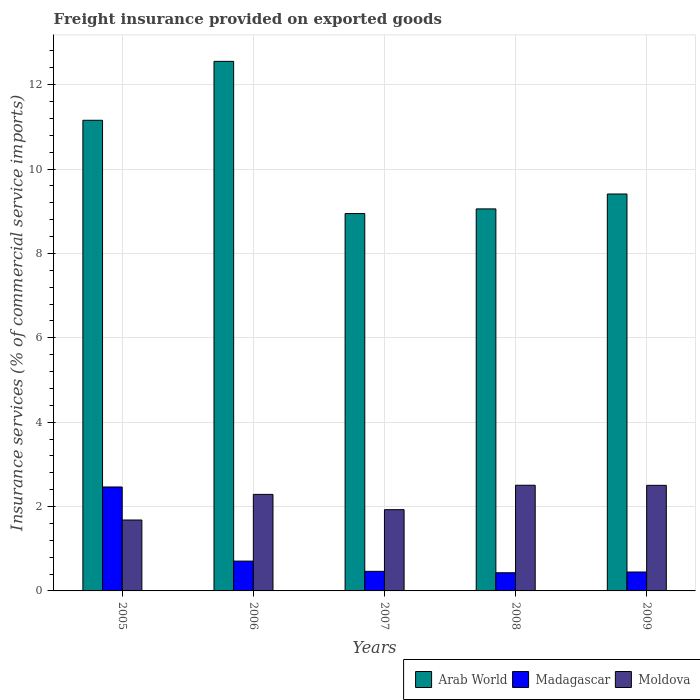How many different coloured bars are there?
Give a very brief answer. 3. How many groups of bars are there?
Ensure brevity in your answer.  5. How many bars are there on the 4th tick from the left?
Offer a very short reply. 3. What is the freight insurance provided on exported goods in Madagascar in 2007?
Your answer should be very brief. 0.46. Across all years, what is the maximum freight insurance provided on exported goods in Moldova?
Make the answer very short. 2.51. Across all years, what is the minimum freight insurance provided on exported goods in Moldova?
Offer a terse response. 1.68. In which year was the freight insurance provided on exported goods in Madagascar maximum?
Your answer should be compact. 2005. In which year was the freight insurance provided on exported goods in Moldova minimum?
Your answer should be compact. 2005. What is the total freight insurance provided on exported goods in Arab World in the graph?
Your answer should be compact. 51.12. What is the difference between the freight insurance provided on exported goods in Moldova in 2007 and that in 2008?
Offer a very short reply. -0.58. What is the difference between the freight insurance provided on exported goods in Moldova in 2008 and the freight insurance provided on exported goods in Madagascar in 2005?
Your response must be concise. 0.04. What is the average freight insurance provided on exported goods in Arab World per year?
Your answer should be compact. 10.22. In the year 2007, what is the difference between the freight insurance provided on exported goods in Arab World and freight insurance provided on exported goods in Moldova?
Provide a succinct answer. 7.02. In how many years, is the freight insurance provided on exported goods in Moldova greater than 3.6 %?
Give a very brief answer. 0. What is the ratio of the freight insurance provided on exported goods in Moldova in 2008 to that in 2009?
Ensure brevity in your answer.  1. Is the freight insurance provided on exported goods in Arab World in 2005 less than that in 2007?
Give a very brief answer. No. Is the difference between the freight insurance provided on exported goods in Arab World in 2007 and 2009 greater than the difference between the freight insurance provided on exported goods in Moldova in 2007 and 2009?
Your response must be concise. Yes. What is the difference between the highest and the second highest freight insurance provided on exported goods in Moldova?
Provide a succinct answer. 0. What is the difference between the highest and the lowest freight insurance provided on exported goods in Madagascar?
Make the answer very short. 2.03. In how many years, is the freight insurance provided on exported goods in Moldova greater than the average freight insurance provided on exported goods in Moldova taken over all years?
Your response must be concise. 3. Is the sum of the freight insurance provided on exported goods in Arab World in 2005 and 2009 greater than the maximum freight insurance provided on exported goods in Madagascar across all years?
Make the answer very short. Yes. What does the 2nd bar from the left in 2005 represents?
Your answer should be very brief. Madagascar. What does the 3rd bar from the right in 2008 represents?
Offer a very short reply. Arab World. Is it the case that in every year, the sum of the freight insurance provided on exported goods in Arab World and freight insurance provided on exported goods in Madagascar is greater than the freight insurance provided on exported goods in Moldova?
Keep it short and to the point. Yes. How many bars are there?
Keep it short and to the point. 15. Are all the bars in the graph horizontal?
Your answer should be very brief. No. How many years are there in the graph?
Provide a short and direct response. 5. What is the difference between two consecutive major ticks on the Y-axis?
Your answer should be compact. 2. Does the graph contain any zero values?
Your response must be concise. No. Does the graph contain grids?
Your answer should be compact. Yes. What is the title of the graph?
Make the answer very short. Freight insurance provided on exported goods. Does "Kuwait" appear as one of the legend labels in the graph?
Ensure brevity in your answer.  No. What is the label or title of the Y-axis?
Make the answer very short. Insurance services (% of commercial service imports). What is the Insurance services (% of commercial service imports) in Arab World in 2005?
Give a very brief answer. 11.16. What is the Insurance services (% of commercial service imports) in Madagascar in 2005?
Your response must be concise. 2.46. What is the Insurance services (% of commercial service imports) of Moldova in 2005?
Give a very brief answer. 1.68. What is the Insurance services (% of commercial service imports) of Arab World in 2006?
Your answer should be compact. 12.55. What is the Insurance services (% of commercial service imports) in Madagascar in 2006?
Provide a succinct answer. 0.71. What is the Insurance services (% of commercial service imports) of Moldova in 2006?
Provide a short and direct response. 2.29. What is the Insurance services (% of commercial service imports) in Arab World in 2007?
Your response must be concise. 8.95. What is the Insurance services (% of commercial service imports) of Madagascar in 2007?
Your answer should be compact. 0.46. What is the Insurance services (% of commercial service imports) of Moldova in 2007?
Ensure brevity in your answer.  1.93. What is the Insurance services (% of commercial service imports) in Arab World in 2008?
Offer a very short reply. 9.06. What is the Insurance services (% of commercial service imports) in Madagascar in 2008?
Give a very brief answer. 0.43. What is the Insurance services (% of commercial service imports) in Moldova in 2008?
Your response must be concise. 2.51. What is the Insurance services (% of commercial service imports) in Arab World in 2009?
Offer a terse response. 9.41. What is the Insurance services (% of commercial service imports) in Madagascar in 2009?
Make the answer very short. 0.45. What is the Insurance services (% of commercial service imports) of Moldova in 2009?
Give a very brief answer. 2.5. Across all years, what is the maximum Insurance services (% of commercial service imports) of Arab World?
Keep it short and to the point. 12.55. Across all years, what is the maximum Insurance services (% of commercial service imports) in Madagascar?
Ensure brevity in your answer.  2.46. Across all years, what is the maximum Insurance services (% of commercial service imports) in Moldova?
Keep it short and to the point. 2.51. Across all years, what is the minimum Insurance services (% of commercial service imports) in Arab World?
Make the answer very short. 8.95. Across all years, what is the minimum Insurance services (% of commercial service imports) of Madagascar?
Make the answer very short. 0.43. Across all years, what is the minimum Insurance services (% of commercial service imports) of Moldova?
Your answer should be compact. 1.68. What is the total Insurance services (% of commercial service imports) in Arab World in the graph?
Your answer should be compact. 51.12. What is the total Insurance services (% of commercial service imports) in Madagascar in the graph?
Keep it short and to the point. 4.51. What is the total Insurance services (% of commercial service imports) of Moldova in the graph?
Your answer should be very brief. 10.9. What is the difference between the Insurance services (% of commercial service imports) in Arab World in 2005 and that in 2006?
Provide a short and direct response. -1.4. What is the difference between the Insurance services (% of commercial service imports) in Madagascar in 2005 and that in 2006?
Offer a terse response. 1.76. What is the difference between the Insurance services (% of commercial service imports) of Moldova in 2005 and that in 2006?
Give a very brief answer. -0.61. What is the difference between the Insurance services (% of commercial service imports) in Arab World in 2005 and that in 2007?
Give a very brief answer. 2.21. What is the difference between the Insurance services (% of commercial service imports) of Madagascar in 2005 and that in 2007?
Your answer should be very brief. 2. What is the difference between the Insurance services (% of commercial service imports) in Moldova in 2005 and that in 2007?
Your answer should be very brief. -0.25. What is the difference between the Insurance services (% of commercial service imports) in Arab World in 2005 and that in 2008?
Your answer should be very brief. 2.1. What is the difference between the Insurance services (% of commercial service imports) in Madagascar in 2005 and that in 2008?
Your answer should be compact. 2.03. What is the difference between the Insurance services (% of commercial service imports) in Moldova in 2005 and that in 2008?
Provide a succinct answer. -0.82. What is the difference between the Insurance services (% of commercial service imports) in Arab World in 2005 and that in 2009?
Your response must be concise. 1.75. What is the difference between the Insurance services (% of commercial service imports) of Madagascar in 2005 and that in 2009?
Keep it short and to the point. 2.02. What is the difference between the Insurance services (% of commercial service imports) of Moldova in 2005 and that in 2009?
Provide a succinct answer. -0.82. What is the difference between the Insurance services (% of commercial service imports) of Arab World in 2006 and that in 2007?
Keep it short and to the point. 3.61. What is the difference between the Insurance services (% of commercial service imports) of Madagascar in 2006 and that in 2007?
Keep it short and to the point. 0.24. What is the difference between the Insurance services (% of commercial service imports) of Moldova in 2006 and that in 2007?
Ensure brevity in your answer.  0.36. What is the difference between the Insurance services (% of commercial service imports) in Arab World in 2006 and that in 2008?
Provide a short and direct response. 3.5. What is the difference between the Insurance services (% of commercial service imports) in Madagascar in 2006 and that in 2008?
Provide a short and direct response. 0.28. What is the difference between the Insurance services (% of commercial service imports) in Moldova in 2006 and that in 2008?
Give a very brief answer. -0.22. What is the difference between the Insurance services (% of commercial service imports) in Arab World in 2006 and that in 2009?
Offer a very short reply. 3.14. What is the difference between the Insurance services (% of commercial service imports) in Madagascar in 2006 and that in 2009?
Make the answer very short. 0.26. What is the difference between the Insurance services (% of commercial service imports) of Moldova in 2006 and that in 2009?
Keep it short and to the point. -0.21. What is the difference between the Insurance services (% of commercial service imports) of Arab World in 2007 and that in 2008?
Make the answer very short. -0.11. What is the difference between the Insurance services (% of commercial service imports) in Madagascar in 2007 and that in 2008?
Your answer should be compact. 0.03. What is the difference between the Insurance services (% of commercial service imports) in Moldova in 2007 and that in 2008?
Ensure brevity in your answer.  -0.58. What is the difference between the Insurance services (% of commercial service imports) of Arab World in 2007 and that in 2009?
Your answer should be very brief. -0.46. What is the difference between the Insurance services (% of commercial service imports) in Madagascar in 2007 and that in 2009?
Give a very brief answer. 0.02. What is the difference between the Insurance services (% of commercial service imports) in Moldova in 2007 and that in 2009?
Provide a succinct answer. -0.58. What is the difference between the Insurance services (% of commercial service imports) in Arab World in 2008 and that in 2009?
Keep it short and to the point. -0.35. What is the difference between the Insurance services (% of commercial service imports) in Madagascar in 2008 and that in 2009?
Your answer should be very brief. -0.02. What is the difference between the Insurance services (% of commercial service imports) of Moldova in 2008 and that in 2009?
Make the answer very short. 0. What is the difference between the Insurance services (% of commercial service imports) of Arab World in 2005 and the Insurance services (% of commercial service imports) of Madagascar in 2006?
Ensure brevity in your answer.  10.45. What is the difference between the Insurance services (% of commercial service imports) of Arab World in 2005 and the Insurance services (% of commercial service imports) of Moldova in 2006?
Ensure brevity in your answer.  8.87. What is the difference between the Insurance services (% of commercial service imports) of Madagascar in 2005 and the Insurance services (% of commercial service imports) of Moldova in 2006?
Your answer should be compact. 0.18. What is the difference between the Insurance services (% of commercial service imports) of Arab World in 2005 and the Insurance services (% of commercial service imports) of Madagascar in 2007?
Provide a succinct answer. 10.69. What is the difference between the Insurance services (% of commercial service imports) of Arab World in 2005 and the Insurance services (% of commercial service imports) of Moldova in 2007?
Your answer should be very brief. 9.23. What is the difference between the Insurance services (% of commercial service imports) of Madagascar in 2005 and the Insurance services (% of commercial service imports) of Moldova in 2007?
Provide a short and direct response. 0.54. What is the difference between the Insurance services (% of commercial service imports) of Arab World in 2005 and the Insurance services (% of commercial service imports) of Madagascar in 2008?
Ensure brevity in your answer.  10.73. What is the difference between the Insurance services (% of commercial service imports) of Arab World in 2005 and the Insurance services (% of commercial service imports) of Moldova in 2008?
Your response must be concise. 8.65. What is the difference between the Insurance services (% of commercial service imports) in Madagascar in 2005 and the Insurance services (% of commercial service imports) in Moldova in 2008?
Provide a short and direct response. -0.04. What is the difference between the Insurance services (% of commercial service imports) of Arab World in 2005 and the Insurance services (% of commercial service imports) of Madagascar in 2009?
Your response must be concise. 10.71. What is the difference between the Insurance services (% of commercial service imports) in Arab World in 2005 and the Insurance services (% of commercial service imports) in Moldova in 2009?
Provide a short and direct response. 8.65. What is the difference between the Insurance services (% of commercial service imports) of Madagascar in 2005 and the Insurance services (% of commercial service imports) of Moldova in 2009?
Your answer should be compact. -0.04. What is the difference between the Insurance services (% of commercial service imports) in Arab World in 2006 and the Insurance services (% of commercial service imports) in Madagascar in 2007?
Provide a succinct answer. 12.09. What is the difference between the Insurance services (% of commercial service imports) in Arab World in 2006 and the Insurance services (% of commercial service imports) in Moldova in 2007?
Make the answer very short. 10.63. What is the difference between the Insurance services (% of commercial service imports) in Madagascar in 2006 and the Insurance services (% of commercial service imports) in Moldova in 2007?
Offer a very short reply. -1.22. What is the difference between the Insurance services (% of commercial service imports) in Arab World in 2006 and the Insurance services (% of commercial service imports) in Madagascar in 2008?
Provide a succinct answer. 12.12. What is the difference between the Insurance services (% of commercial service imports) in Arab World in 2006 and the Insurance services (% of commercial service imports) in Moldova in 2008?
Ensure brevity in your answer.  10.05. What is the difference between the Insurance services (% of commercial service imports) in Madagascar in 2006 and the Insurance services (% of commercial service imports) in Moldova in 2008?
Give a very brief answer. -1.8. What is the difference between the Insurance services (% of commercial service imports) of Arab World in 2006 and the Insurance services (% of commercial service imports) of Madagascar in 2009?
Your answer should be compact. 12.11. What is the difference between the Insurance services (% of commercial service imports) in Arab World in 2006 and the Insurance services (% of commercial service imports) in Moldova in 2009?
Offer a very short reply. 10.05. What is the difference between the Insurance services (% of commercial service imports) in Madagascar in 2006 and the Insurance services (% of commercial service imports) in Moldova in 2009?
Your answer should be very brief. -1.8. What is the difference between the Insurance services (% of commercial service imports) in Arab World in 2007 and the Insurance services (% of commercial service imports) in Madagascar in 2008?
Your answer should be very brief. 8.52. What is the difference between the Insurance services (% of commercial service imports) in Arab World in 2007 and the Insurance services (% of commercial service imports) in Moldova in 2008?
Ensure brevity in your answer.  6.44. What is the difference between the Insurance services (% of commercial service imports) of Madagascar in 2007 and the Insurance services (% of commercial service imports) of Moldova in 2008?
Keep it short and to the point. -2.04. What is the difference between the Insurance services (% of commercial service imports) of Arab World in 2007 and the Insurance services (% of commercial service imports) of Madagascar in 2009?
Your answer should be very brief. 8.5. What is the difference between the Insurance services (% of commercial service imports) of Arab World in 2007 and the Insurance services (% of commercial service imports) of Moldova in 2009?
Give a very brief answer. 6.44. What is the difference between the Insurance services (% of commercial service imports) in Madagascar in 2007 and the Insurance services (% of commercial service imports) in Moldova in 2009?
Make the answer very short. -2.04. What is the difference between the Insurance services (% of commercial service imports) in Arab World in 2008 and the Insurance services (% of commercial service imports) in Madagascar in 2009?
Offer a very short reply. 8.61. What is the difference between the Insurance services (% of commercial service imports) of Arab World in 2008 and the Insurance services (% of commercial service imports) of Moldova in 2009?
Provide a short and direct response. 6.55. What is the difference between the Insurance services (% of commercial service imports) of Madagascar in 2008 and the Insurance services (% of commercial service imports) of Moldova in 2009?
Your answer should be compact. -2.07. What is the average Insurance services (% of commercial service imports) of Arab World per year?
Give a very brief answer. 10.22. What is the average Insurance services (% of commercial service imports) of Madagascar per year?
Your response must be concise. 0.9. What is the average Insurance services (% of commercial service imports) of Moldova per year?
Make the answer very short. 2.18. In the year 2005, what is the difference between the Insurance services (% of commercial service imports) in Arab World and Insurance services (% of commercial service imports) in Madagascar?
Your answer should be very brief. 8.69. In the year 2005, what is the difference between the Insurance services (% of commercial service imports) in Arab World and Insurance services (% of commercial service imports) in Moldova?
Provide a short and direct response. 9.48. In the year 2005, what is the difference between the Insurance services (% of commercial service imports) of Madagascar and Insurance services (% of commercial service imports) of Moldova?
Your answer should be compact. 0.78. In the year 2006, what is the difference between the Insurance services (% of commercial service imports) in Arab World and Insurance services (% of commercial service imports) in Madagascar?
Offer a very short reply. 11.85. In the year 2006, what is the difference between the Insurance services (% of commercial service imports) in Arab World and Insurance services (% of commercial service imports) in Moldova?
Give a very brief answer. 10.27. In the year 2006, what is the difference between the Insurance services (% of commercial service imports) of Madagascar and Insurance services (% of commercial service imports) of Moldova?
Provide a short and direct response. -1.58. In the year 2007, what is the difference between the Insurance services (% of commercial service imports) in Arab World and Insurance services (% of commercial service imports) in Madagascar?
Ensure brevity in your answer.  8.48. In the year 2007, what is the difference between the Insurance services (% of commercial service imports) in Arab World and Insurance services (% of commercial service imports) in Moldova?
Give a very brief answer. 7.02. In the year 2007, what is the difference between the Insurance services (% of commercial service imports) in Madagascar and Insurance services (% of commercial service imports) in Moldova?
Your answer should be compact. -1.46. In the year 2008, what is the difference between the Insurance services (% of commercial service imports) of Arab World and Insurance services (% of commercial service imports) of Madagascar?
Give a very brief answer. 8.63. In the year 2008, what is the difference between the Insurance services (% of commercial service imports) of Arab World and Insurance services (% of commercial service imports) of Moldova?
Keep it short and to the point. 6.55. In the year 2008, what is the difference between the Insurance services (% of commercial service imports) of Madagascar and Insurance services (% of commercial service imports) of Moldova?
Offer a terse response. -2.07. In the year 2009, what is the difference between the Insurance services (% of commercial service imports) in Arab World and Insurance services (% of commercial service imports) in Madagascar?
Provide a short and direct response. 8.96. In the year 2009, what is the difference between the Insurance services (% of commercial service imports) of Arab World and Insurance services (% of commercial service imports) of Moldova?
Your response must be concise. 6.91. In the year 2009, what is the difference between the Insurance services (% of commercial service imports) of Madagascar and Insurance services (% of commercial service imports) of Moldova?
Give a very brief answer. -2.05. What is the ratio of the Insurance services (% of commercial service imports) in Arab World in 2005 to that in 2006?
Give a very brief answer. 0.89. What is the ratio of the Insurance services (% of commercial service imports) of Madagascar in 2005 to that in 2006?
Provide a short and direct response. 3.49. What is the ratio of the Insurance services (% of commercial service imports) in Moldova in 2005 to that in 2006?
Give a very brief answer. 0.73. What is the ratio of the Insurance services (% of commercial service imports) of Arab World in 2005 to that in 2007?
Your answer should be very brief. 1.25. What is the ratio of the Insurance services (% of commercial service imports) in Madagascar in 2005 to that in 2007?
Offer a terse response. 5.31. What is the ratio of the Insurance services (% of commercial service imports) in Moldova in 2005 to that in 2007?
Offer a very short reply. 0.87. What is the ratio of the Insurance services (% of commercial service imports) in Arab World in 2005 to that in 2008?
Your answer should be compact. 1.23. What is the ratio of the Insurance services (% of commercial service imports) of Madagascar in 2005 to that in 2008?
Provide a succinct answer. 5.72. What is the ratio of the Insurance services (% of commercial service imports) in Moldova in 2005 to that in 2008?
Keep it short and to the point. 0.67. What is the ratio of the Insurance services (% of commercial service imports) of Arab World in 2005 to that in 2009?
Provide a succinct answer. 1.19. What is the ratio of the Insurance services (% of commercial service imports) in Madagascar in 2005 to that in 2009?
Keep it short and to the point. 5.49. What is the ratio of the Insurance services (% of commercial service imports) of Moldova in 2005 to that in 2009?
Offer a very short reply. 0.67. What is the ratio of the Insurance services (% of commercial service imports) of Arab World in 2006 to that in 2007?
Offer a terse response. 1.4. What is the ratio of the Insurance services (% of commercial service imports) of Madagascar in 2006 to that in 2007?
Offer a terse response. 1.52. What is the ratio of the Insurance services (% of commercial service imports) in Moldova in 2006 to that in 2007?
Your response must be concise. 1.19. What is the ratio of the Insurance services (% of commercial service imports) in Arab World in 2006 to that in 2008?
Provide a succinct answer. 1.39. What is the ratio of the Insurance services (% of commercial service imports) of Madagascar in 2006 to that in 2008?
Your answer should be very brief. 1.64. What is the ratio of the Insurance services (% of commercial service imports) in Moldova in 2006 to that in 2008?
Your response must be concise. 0.91. What is the ratio of the Insurance services (% of commercial service imports) in Arab World in 2006 to that in 2009?
Make the answer very short. 1.33. What is the ratio of the Insurance services (% of commercial service imports) in Madagascar in 2006 to that in 2009?
Your response must be concise. 1.58. What is the ratio of the Insurance services (% of commercial service imports) of Moldova in 2006 to that in 2009?
Your response must be concise. 0.91. What is the ratio of the Insurance services (% of commercial service imports) of Arab World in 2007 to that in 2008?
Provide a succinct answer. 0.99. What is the ratio of the Insurance services (% of commercial service imports) of Madagascar in 2007 to that in 2008?
Your answer should be compact. 1.08. What is the ratio of the Insurance services (% of commercial service imports) in Moldova in 2007 to that in 2008?
Provide a short and direct response. 0.77. What is the ratio of the Insurance services (% of commercial service imports) of Arab World in 2007 to that in 2009?
Provide a short and direct response. 0.95. What is the ratio of the Insurance services (% of commercial service imports) of Madagascar in 2007 to that in 2009?
Your answer should be compact. 1.04. What is the ratio of the Insurance services (% of commercial service imports) of Moldova in 2007 to that in 2009?
Provide a short and direct response. 0.77. What is the ratio of the Insurance services (% of commercial service imports) of Arab World in 2008 to that in 2009?
Give a very brief answer. 0.96. What is the ratio of the Insurance services (% of commercial service imports) of Madagascar in 2008 to that in 2009?
Make the answer very short. 0.96. What is the ratio of the Insurance services (% of commercial service imports) of Moldova in 2008 to that in 2009?
Keep it short and to the point. 1. What is the difference between the highest and the second highest Insurance services (% of commercial service imports) in Arab World?
Provide a short and direct response. 1.4. What is the difference between the highest and the second highest Insurance services (% of commercial service imports) in Madagascar?
Offer a terse response. 1.76. What is the difference between the highest and the second highest Insurance services (% of commercial service imports) of Moldova?
Provide a succinct answer. 0. What is the difference between the highest and the lowest Insurance services (% of commercial service imports) in Arab World?
Ensure brevity in your answer.  3.61. What is the difference between the highest and the lowest Insurance services (% of commercial service imports) in Madagascar?
Provide a short and direct response. 2.03. What is the difference between the highest and the lowest Insurance services (% of commercial service imports) in Moldova?
Make the answer very short. 0.82. 